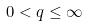<formula> <loc_0><loc_0><loc_500><loc_500>0 < q \leq \infty</formula> 